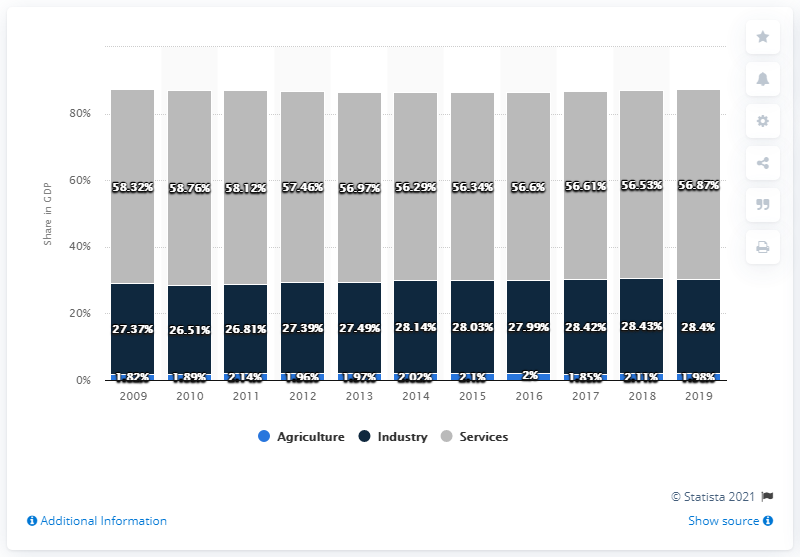Highlight a few significant elements in this photo. In 2019, industry accounted for 28.4% of Slovenia's Gross Domestic Product (GDP). In 2019, agriculture accounted for 1.98% of Slovenia's gross domestic product. 